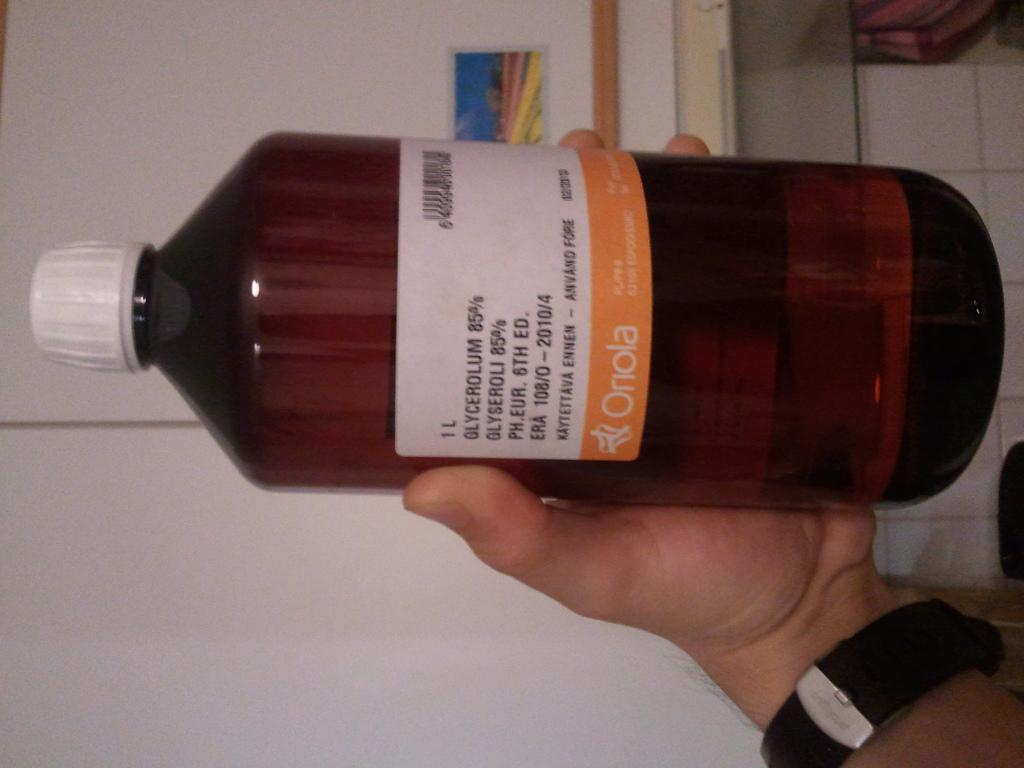<image>
Render a clear and concise summary of the photo. A hand holding up a 1L bottle of some type of liquid. 